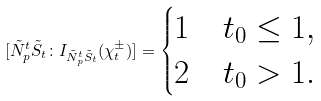<formula> <loc_0><loc_0><loc_500><loc_500>[ \tilde { N } _ { p } ^ { t } \tilde { S } _ { t } \colon I _ { \tilde { N } _ { p } ^ { t } \tilde { S } _ { t } } ( \chi _ { t } ^ { \pm } ) ] = \begin{cases} 1 & t _ { 0 } \leq 1 , \\ 2 & t _ { 0 } > 1 . \end{cases}</formula> 